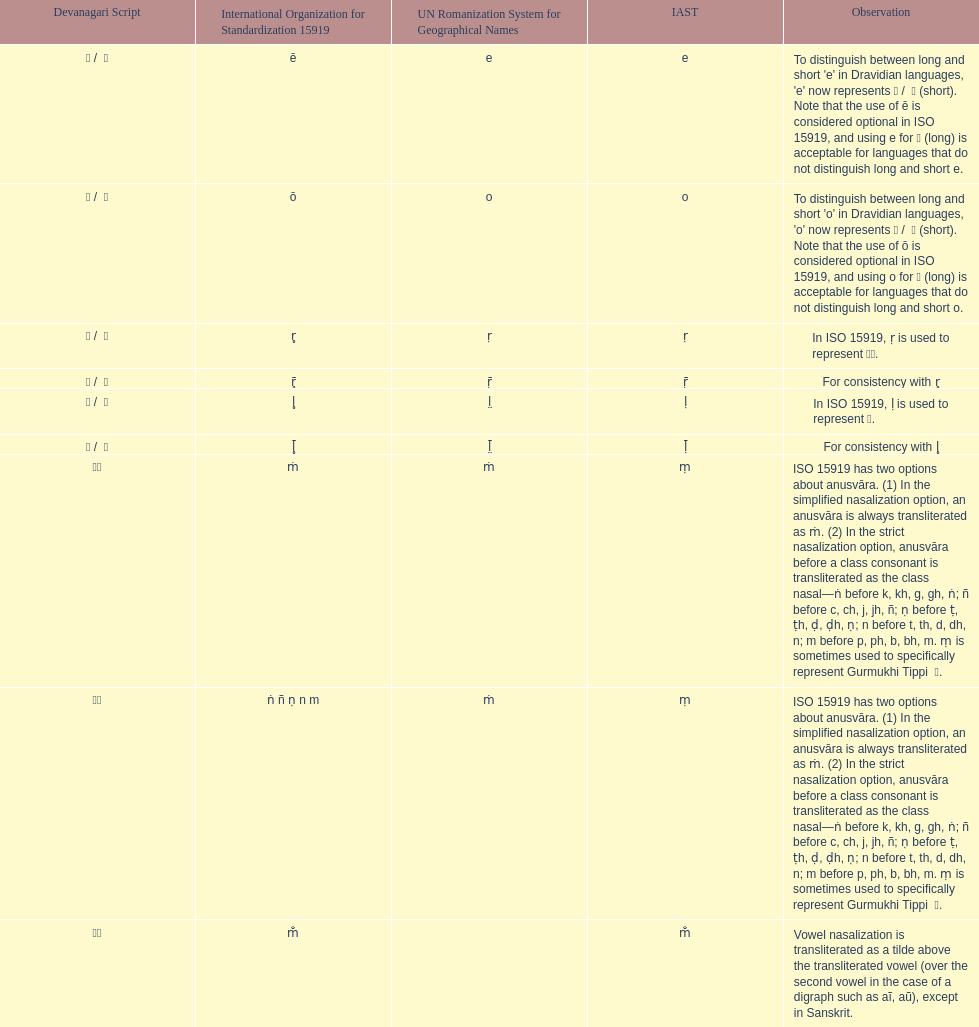Which devanagaria means the same as this iast letter: o? ओ / ो. 